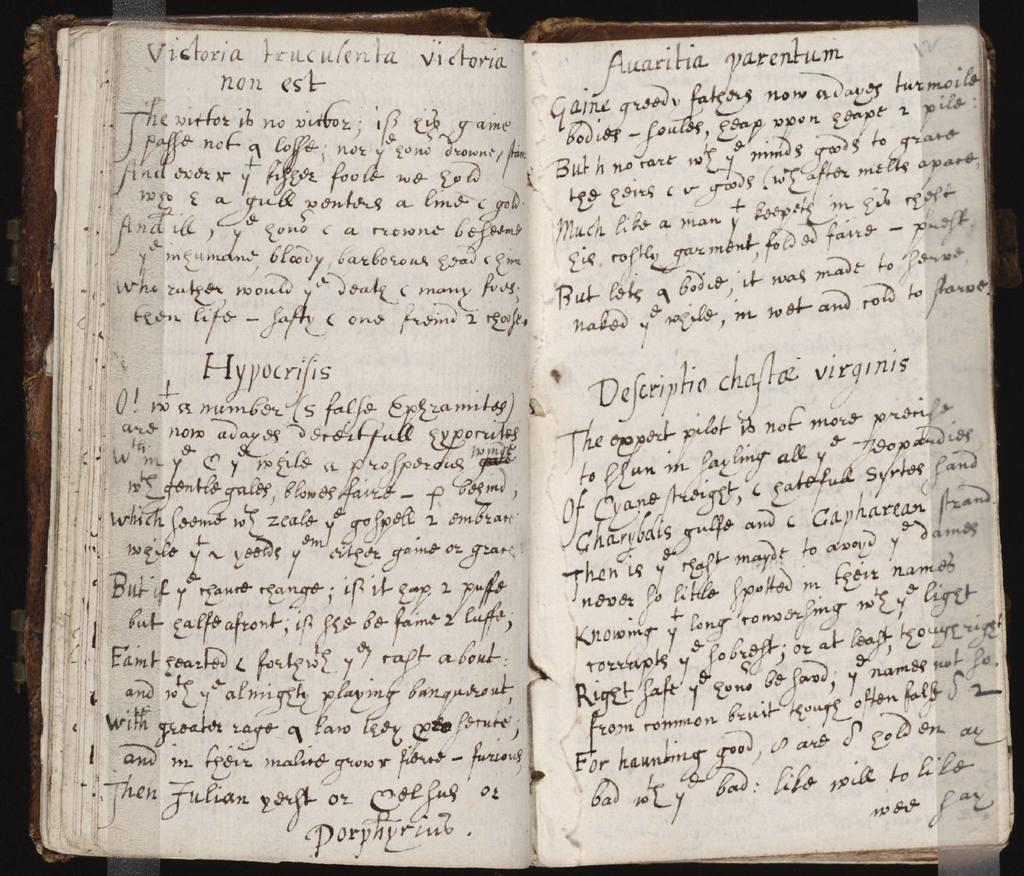<image>
Provide a brief description of the given image. Chapter book that is open about Victoria written in cursive 